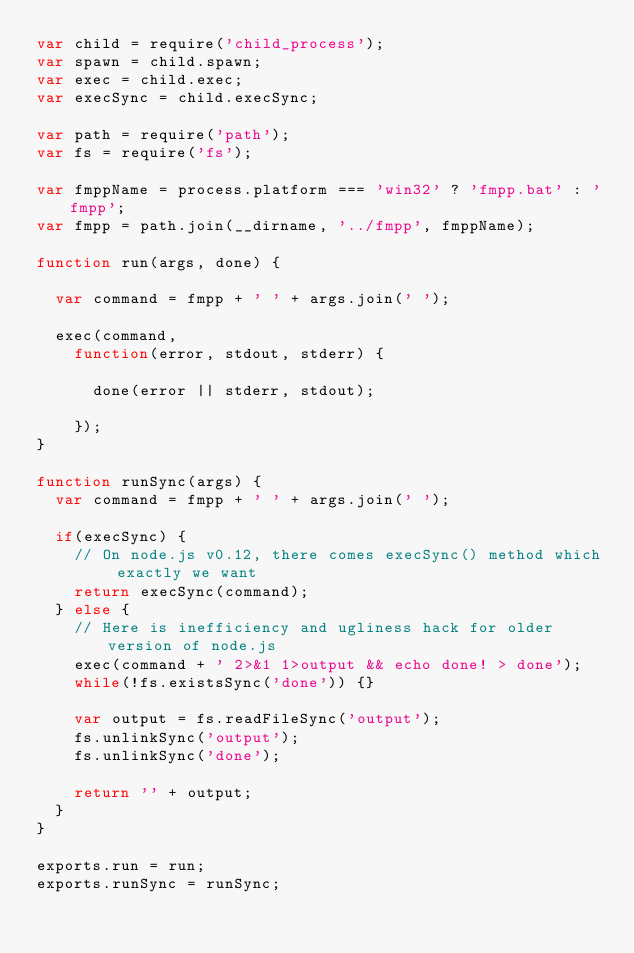Convert code to text. <code><loc_0><loc_0><loc_500><loc_500><_JavaScript_>var child = require('child_process');
var spawn = child.spawn;
var exec = child.exec;
var execSync = child.execSync;

var path = require('path');
var fs = require('fs');

var fmppName = process.platform === 'win32' ? 'fmpp.bat' : 'fmpp';
var fmpp = path.join(__dirname, '../fmpp', fmppName);

function run(args, done) {

  var command = fmpp + ' ' + args.join(' ');

  exec(command,
    function(error, stdout, stderr) {

      done(error || stderr, stdout);

    });
}

function runSync(args) {
  var command = fmpp + ' ' + args.join(' ');

  if(execSync) {
    // On node.js v0.12, there comes execSync() method which exactly we want
    return execSync(command);
  } else {
    // Here is inefficiency and ugliness hack for older version of node.js
    exec(command + ' 2>&1 1>output && echo done! > done');
    while(!fs.existsSync('done')) {}

    var output = fs.readFileSync('output');
    fs.unlinkSync('output');
    fs.unlinkSync('done');

    return '' + output;
  }
}

exports.run = run;
exports.runSync = runSync;
</code> 